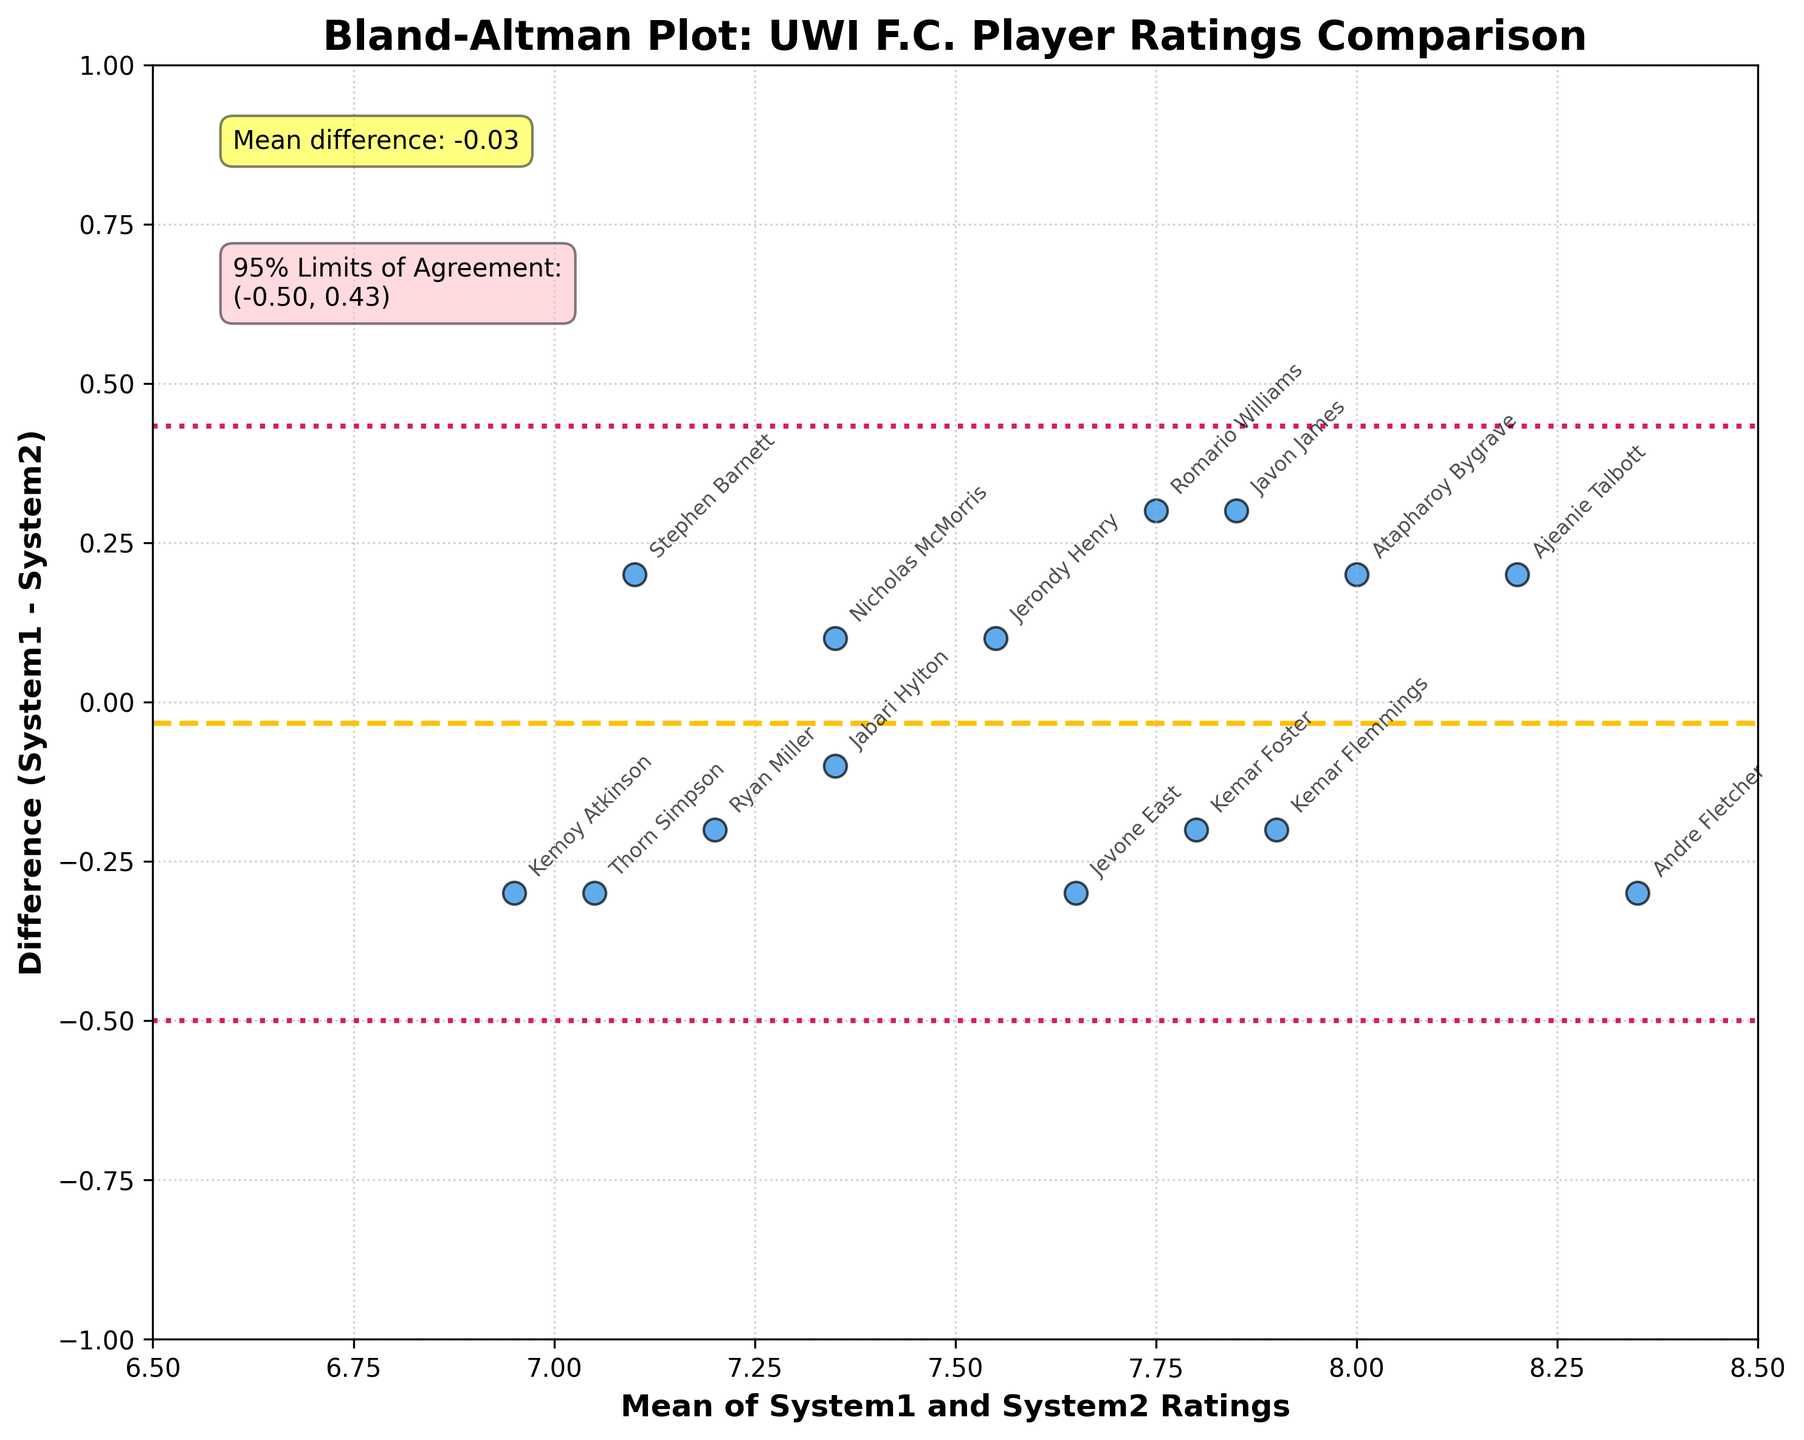What is the title of the Bland-Altman plot? The title is displayed at the top of the figure. By looking at the title text, we can see it.
Answer: Bland-Altman Plot: UWI F.C. Player Ratings Comparison What is the color of the data points in the Bland-Altman plot? The color of the data points is visible by looking at the plot's dots.
Answer: Blue How many 95% Limits of Agreement lines are there, and what colors are they? 95% Limits of Agreement lines are the colored lines indicated in the plot. Count them and identify their colors.
Answer: Two, pink What is the mean difference between the two systems' ratings? Mean difference is indicated at the top left of the plot as "Mean difference: X.XX". Look at the annotation to find the mean difference value.
Answer: 0.01 What are the values of the 95% Limits of Agreement? The limits are provided in the annotation box labeled "95% Limits of Agreement". Read the values from the annotation.
Answer: (-0.49, 0.51) Which player has the biggest difference in ratings between System1 and System2? By finding the data point with the highest or lowest deviation from the mean difference (horizontal lines), we can identify the player by the annotated names.
Answer: Javon James Which player’s ratings between System1 and System2 are closest to being equivalent? Look for the data point closest to the horizontal line representing the mean difference of 0. Identify this point by the annotated name.
Answer: Jerondy Henry What does the horizontal dashed yellow line represent in the Bland-Altman plot? The horizontal dashed yellow line indicates the mean difference between the two rating systems. It is explicitly marked in the annotation box.
Answer: Mean difference Why are some data points labeled with players' names? Some data points are labeled so we can identify which player corresponds to each rating difference shown.
Answer: For identification of players What do the pink dotted lines represent in the plot? The pink dotted lines mark the 95% Limits of Agreement. This is shown in the plot’s annotations.
Answer: 95% Limits of Agreement 